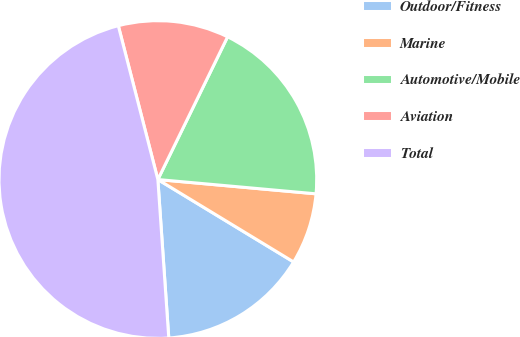<chart> <loc_0><loc_0><loc_500><loc_500><pie_chart><fcel>Outdoor/Fitness<fcel>Marine<fcel>Automotive/Mobile<fcel>Aviation<fcel>Total<nl><fcel>15.22%<fcel>7.25%<fcel>19.2%<fcel>11.24%<fcel>47.09%<nl></chart> 